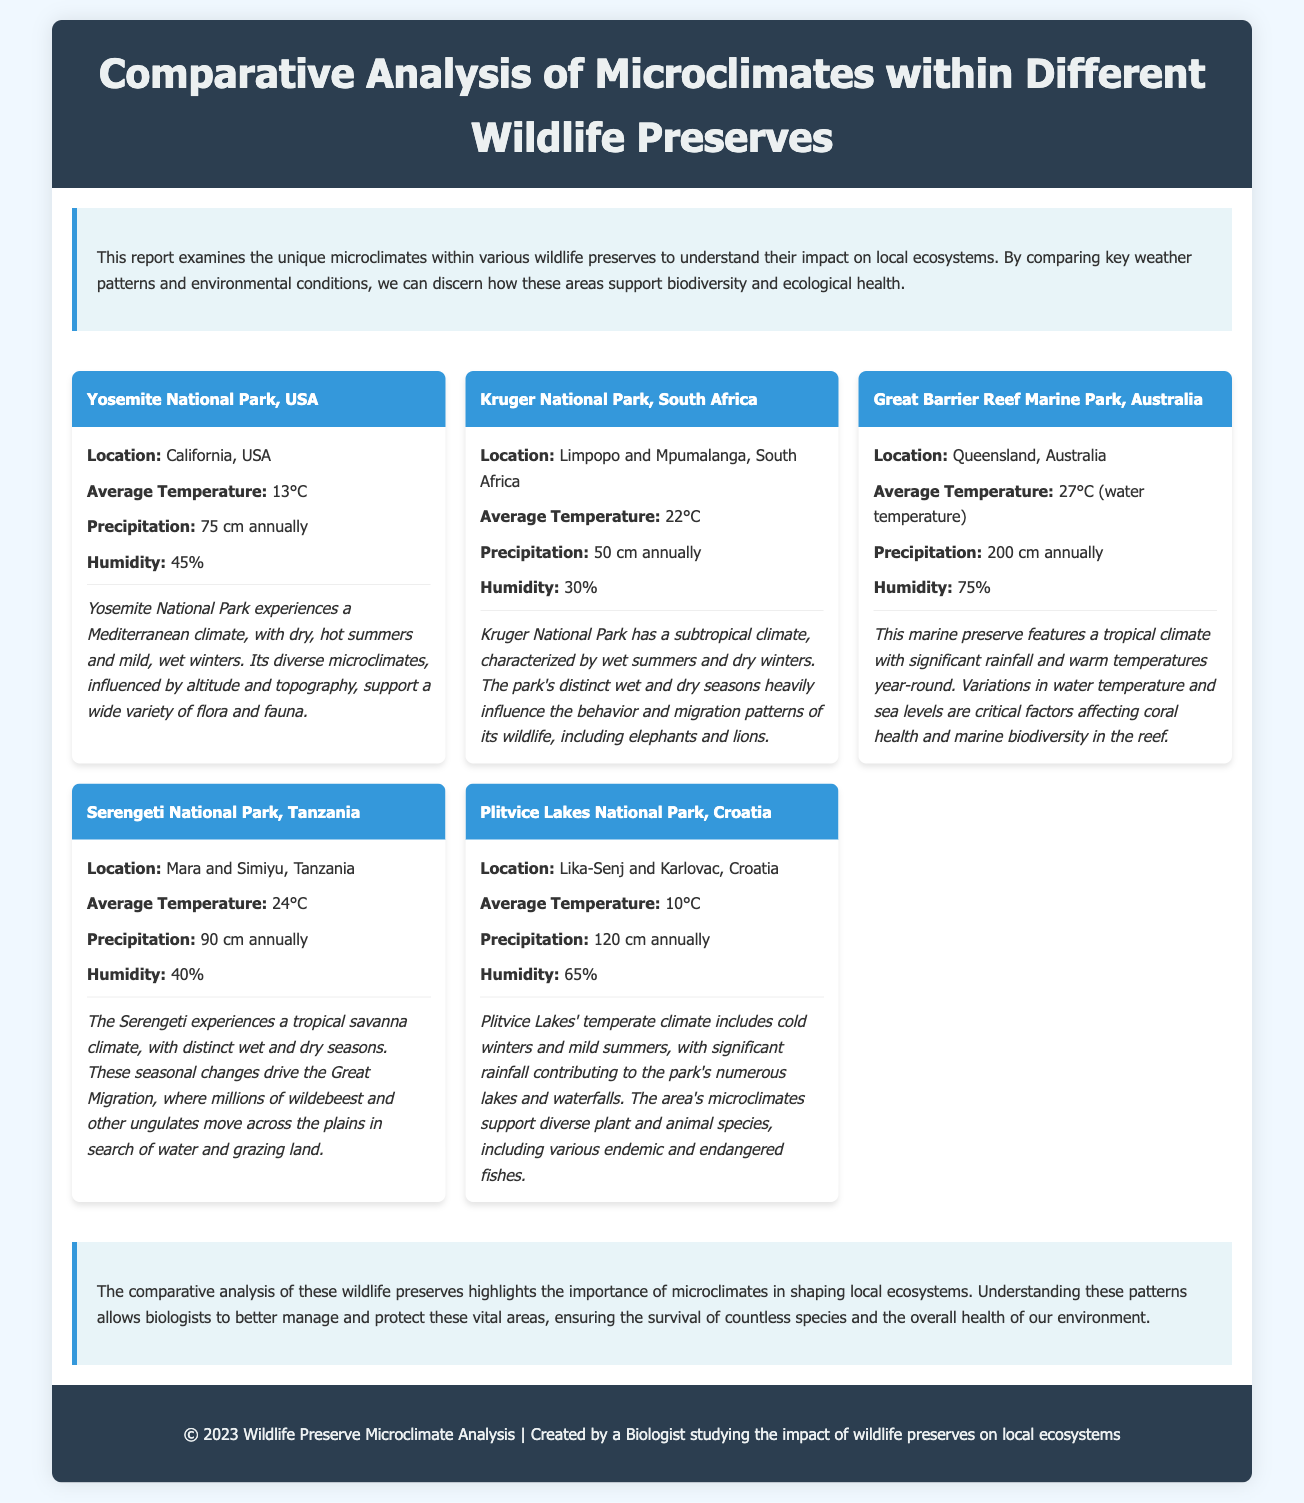What is the average temperature in Yosemite National Park? The average temperature in Yosemite National Park is listed in the document as 13°C.
Answer: 13°C What is the annual precipitation of Great Barrier Reef Marine Park? The document states that the annual precipitation in Great Barrier Reef Marine Park is 200 cm.
Answer: 200 cm Which preserve has the highest humidity? To find the answer, we can compare the humidity levels in the document; Great Barrier Reef Marine Park has the highest at 75%.
Answer: 75% What climate type is associated with Kruger National Park? The document describes Kruger National Park as having a subtropical climate.
Answer: subtropical climate How many centimeters of annual precipitation does Plitvice Lakes National Park receive? Plitvice Lakes National Park's annual precipitation is noted as 120 cm in the document.
Answer: 120 cm Which wildlife preserve experiences the Great Migration? The Great Migration is specifically mentioned in relation to Serengeti National Park in the document.
Answer: Serengeti National Park What is the average temperature of the water in Great Barrier Reef Marine Park? The document specifies the average water temperature in Great Barrier Reef Marine Park as 27°C.
Answer: 27°C What is the main factor affecting coral health in the Great Barrier Reef Marine Park? The document indicates that variations in water temperature and sea levels are critical factors affecting coral health.
Answer: water temperature and sea levels 